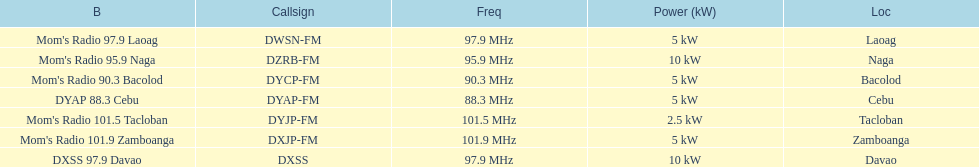What is the radio with the most mhz? Mom's Radio 101.9 Zamboanga. 